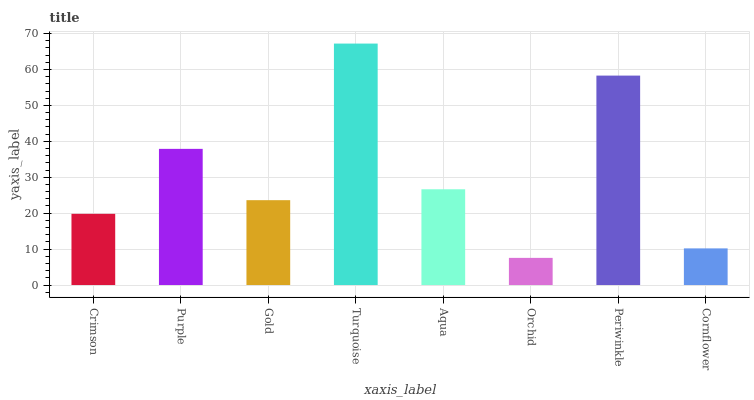Is Purple the minimum?
Answer yes or no. No. Is Purple the maximum?
Answer yes or no. No. Is Purple greater than Crimson?
Answer yes or no. Yes. Is Crimson less than Purple?
Answer yes or no. Yes. Is Crimson greater than Purple?
Answer yes or no. No. Is Purple less than Crimson?
Answer yes or no. No. Is Aqua the high median?
Answer yes or no. Yes. Is Gold the low median?
Answer yes or no. Yes. Is Purple the high median?
Answer yes or no. No. Is Purple the low median?
Answer yes or no. No. 